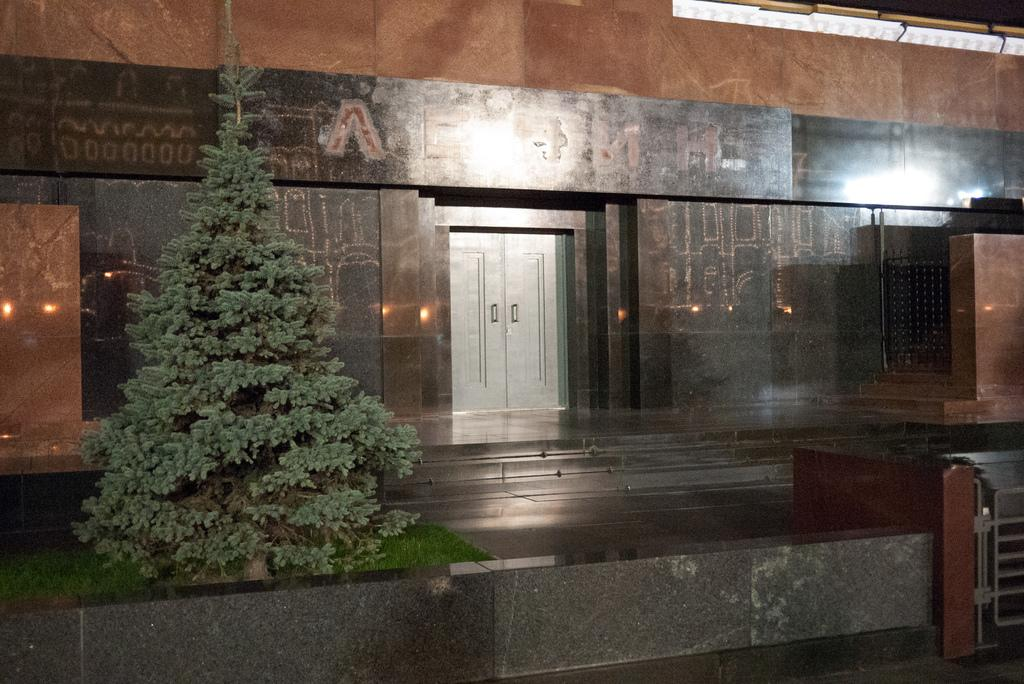What is located on the left side of the image? There is a tree on the left side of the image. What type of terrain is the tree situated on? The tree is on a grassland. What structure is visible behind the tree? There is a building behind the tree. What feature can be seen in the middle of the building? The building has a door in the middle of it. What is on the right side of the image? There is a gate on the right side of the image. What is the gate attached to? The gate is on a wall. How many facts are stitched together to create the image? The image is not made of stitched facts; it is a visual representation of the provided facts. What type of cork can be seen in the image? There is no cork present in the image. 